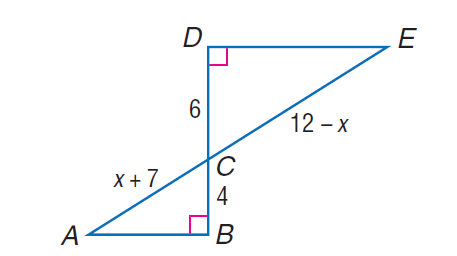Question: Each pair of polygons is similar. Find C E.
Choices:
A. 1.3
B. 5.4
C. 6
D. 11.4
Answer with the letter. Answer: D 